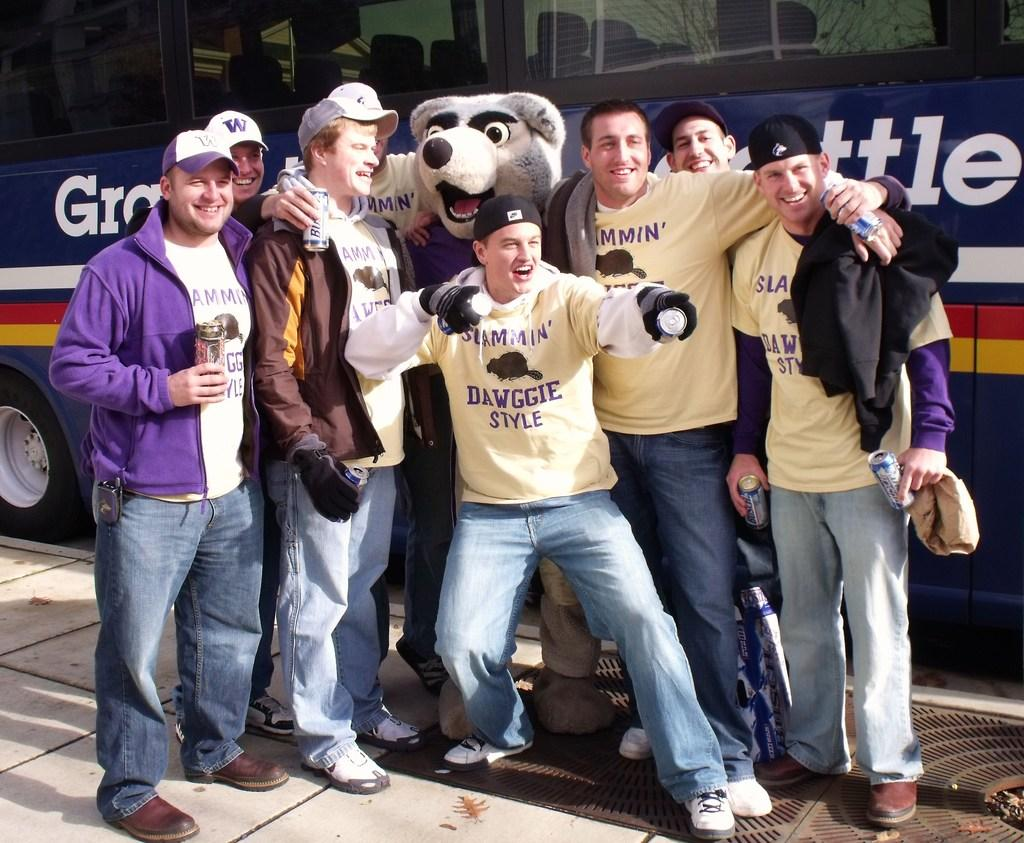What are the men in the image doing? The men in the image are standing and holding beverage bottles. What else can be seen in the image besides the men? There is a person dressed in a costume in the background and a motor vehicle in the background. What type of apparel is the person in the costume wearing? There is no specific apparel mentioned in the image; it only states that there is a person dressed in a costume. What hobbies do the men in the image enjoy? There is no information about the men's hobbies in the image. 